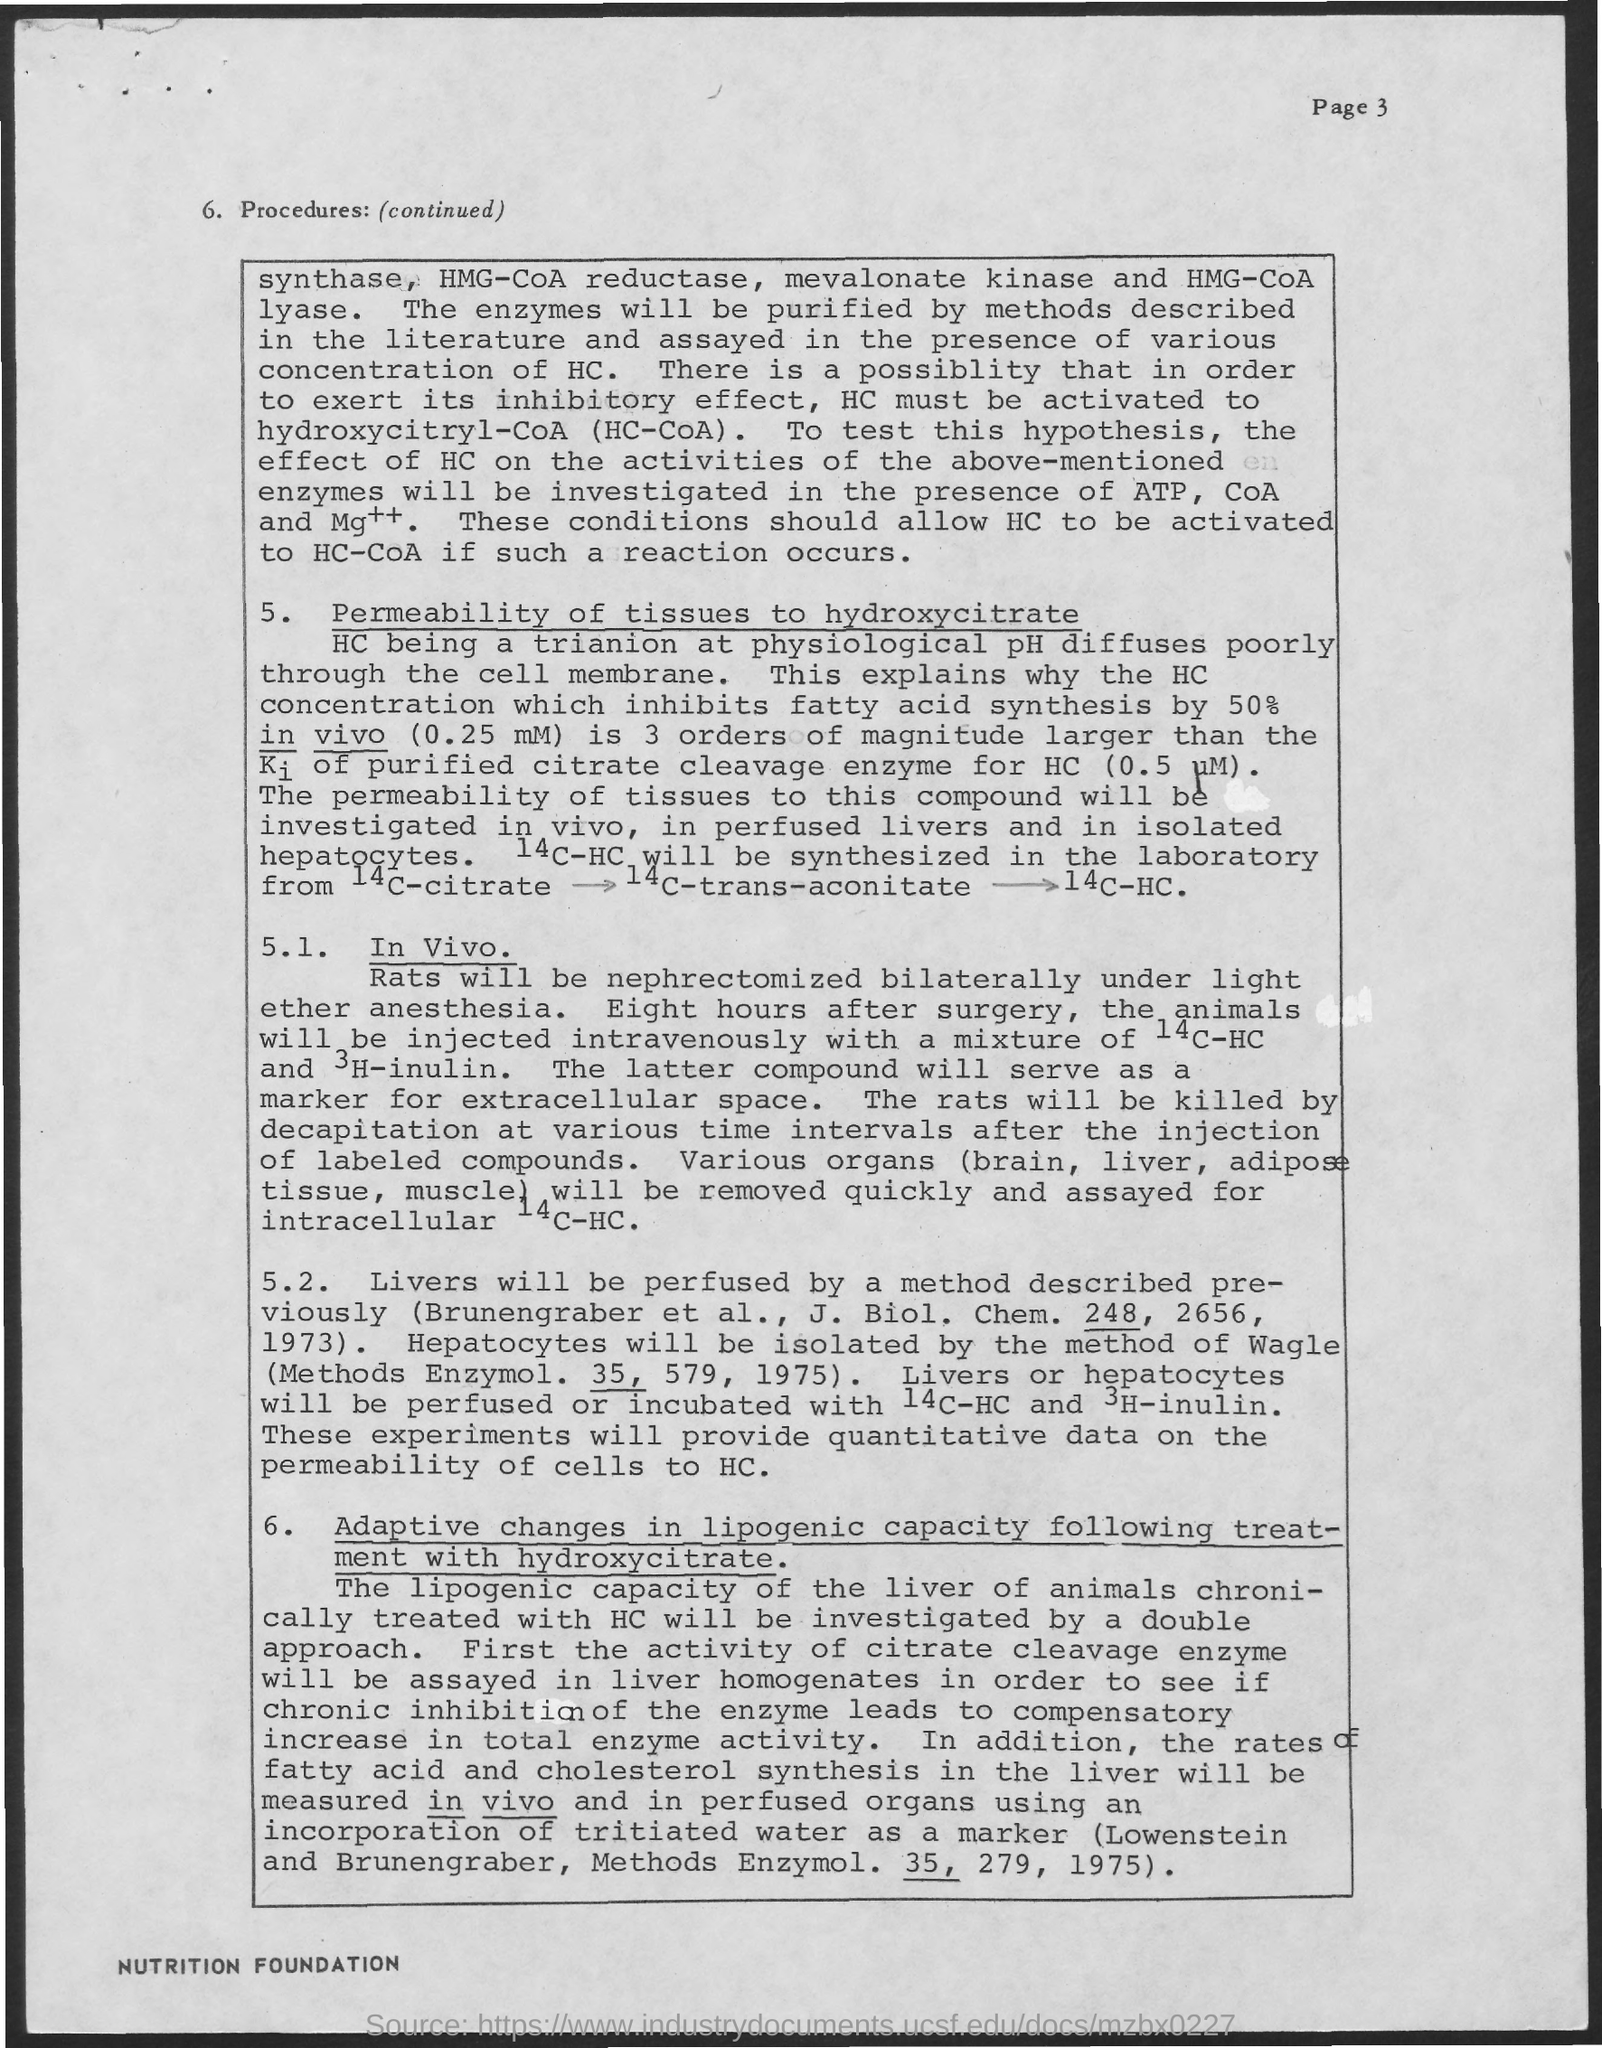Point out several critical features in this image. The inhibitory effect of an enzyme can be determined by activating the substrate, hydroxycitryl-CoA (HC-CoA), and measuring the change in the enzyme's activity. The method used to isolate Hepatocyte cells was developed by Dr. Wagle. 